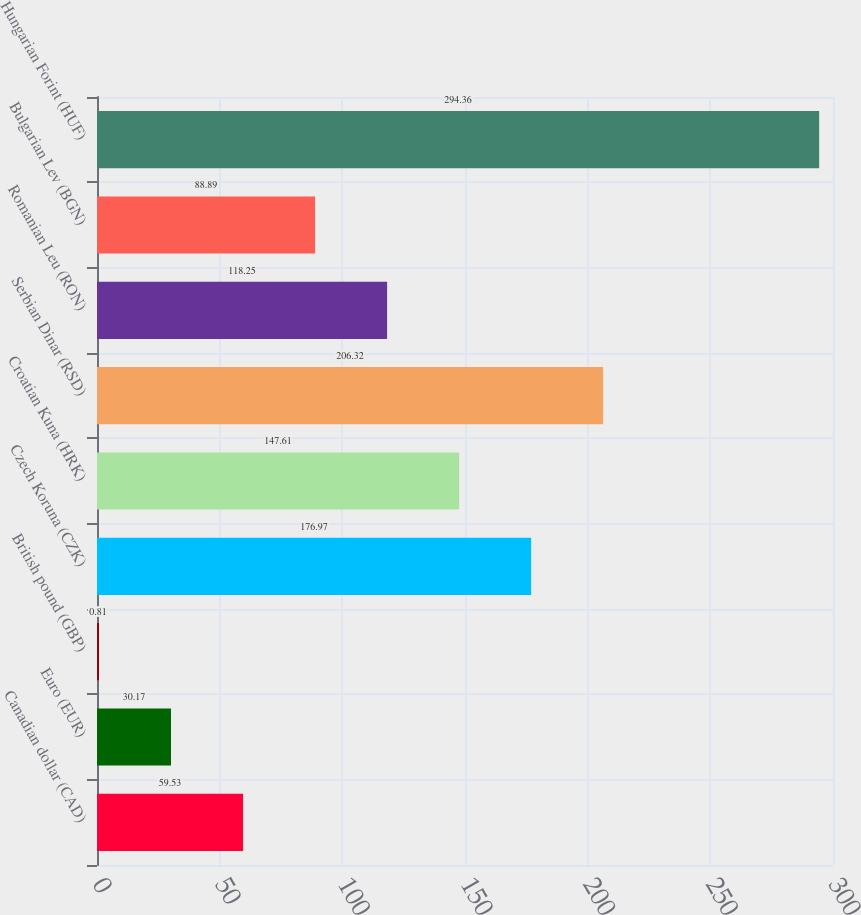<chart> <loc_0><loc_0><loc_500><loc_500><bar_chart><fcel>Canadian dollar (CAD)<fcel>Euro (EUR)<fcel>British pound (GBP)<fcel>Czech Koruna (CZK)<fcel>Croatian Kuna (HRK)<fcel>Serbian Dinar (RSD)<fcel>Romanian Leu (RON)<fcel>Bulgarian Lev (BGN)<fcel>Hungarian Forint (HUF)<nl><fcel>59.53<fcel>30.17<fcel>0.81<fcel>176.97<fcel>147.61<fcel>206.32<fcel>118.25<fcel>88.89<fcel>294.36<nl></chart> 